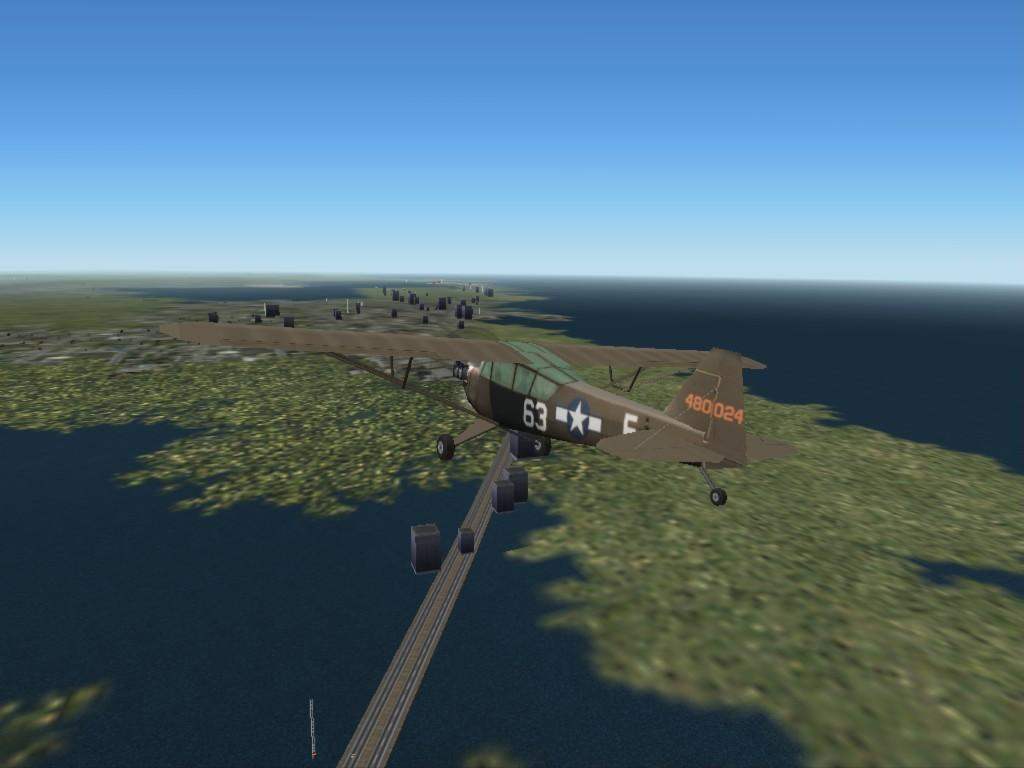<image>
Summarize the visual content of the image. In a computer generated graphic of a plane with the number 63 on it, the plane flies above water. 